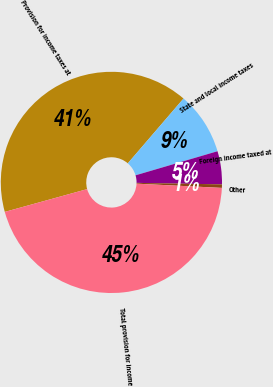<chart> <loc_0><loc_0><loc_500><loc_500><pie_chart><fcel>Provision for income taxes at<fcel>State and local income taxes<fcel>Foreign income taxed at<fcel>Other<fcel>Total provision for income<nl><fcel>40.6%<fcel>9.15%<fcel>4.83%<fcel>0.51%<fcel>44.92%<nl></chart> 